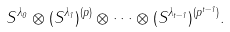Convert formula to latex. <formula><loc_0><loc_0><loc_500><loc_500>S ^ { \lambda _ { 0 } } \otimes ( S ^ { \lambda _ { 1 } } ) ^ { ( p ) } \otimes \cdots \otimes ( S ^ { \lambda _ { t - 1 } } ) ^ { ( p ^ { t - 1 } ) } .</formula> 